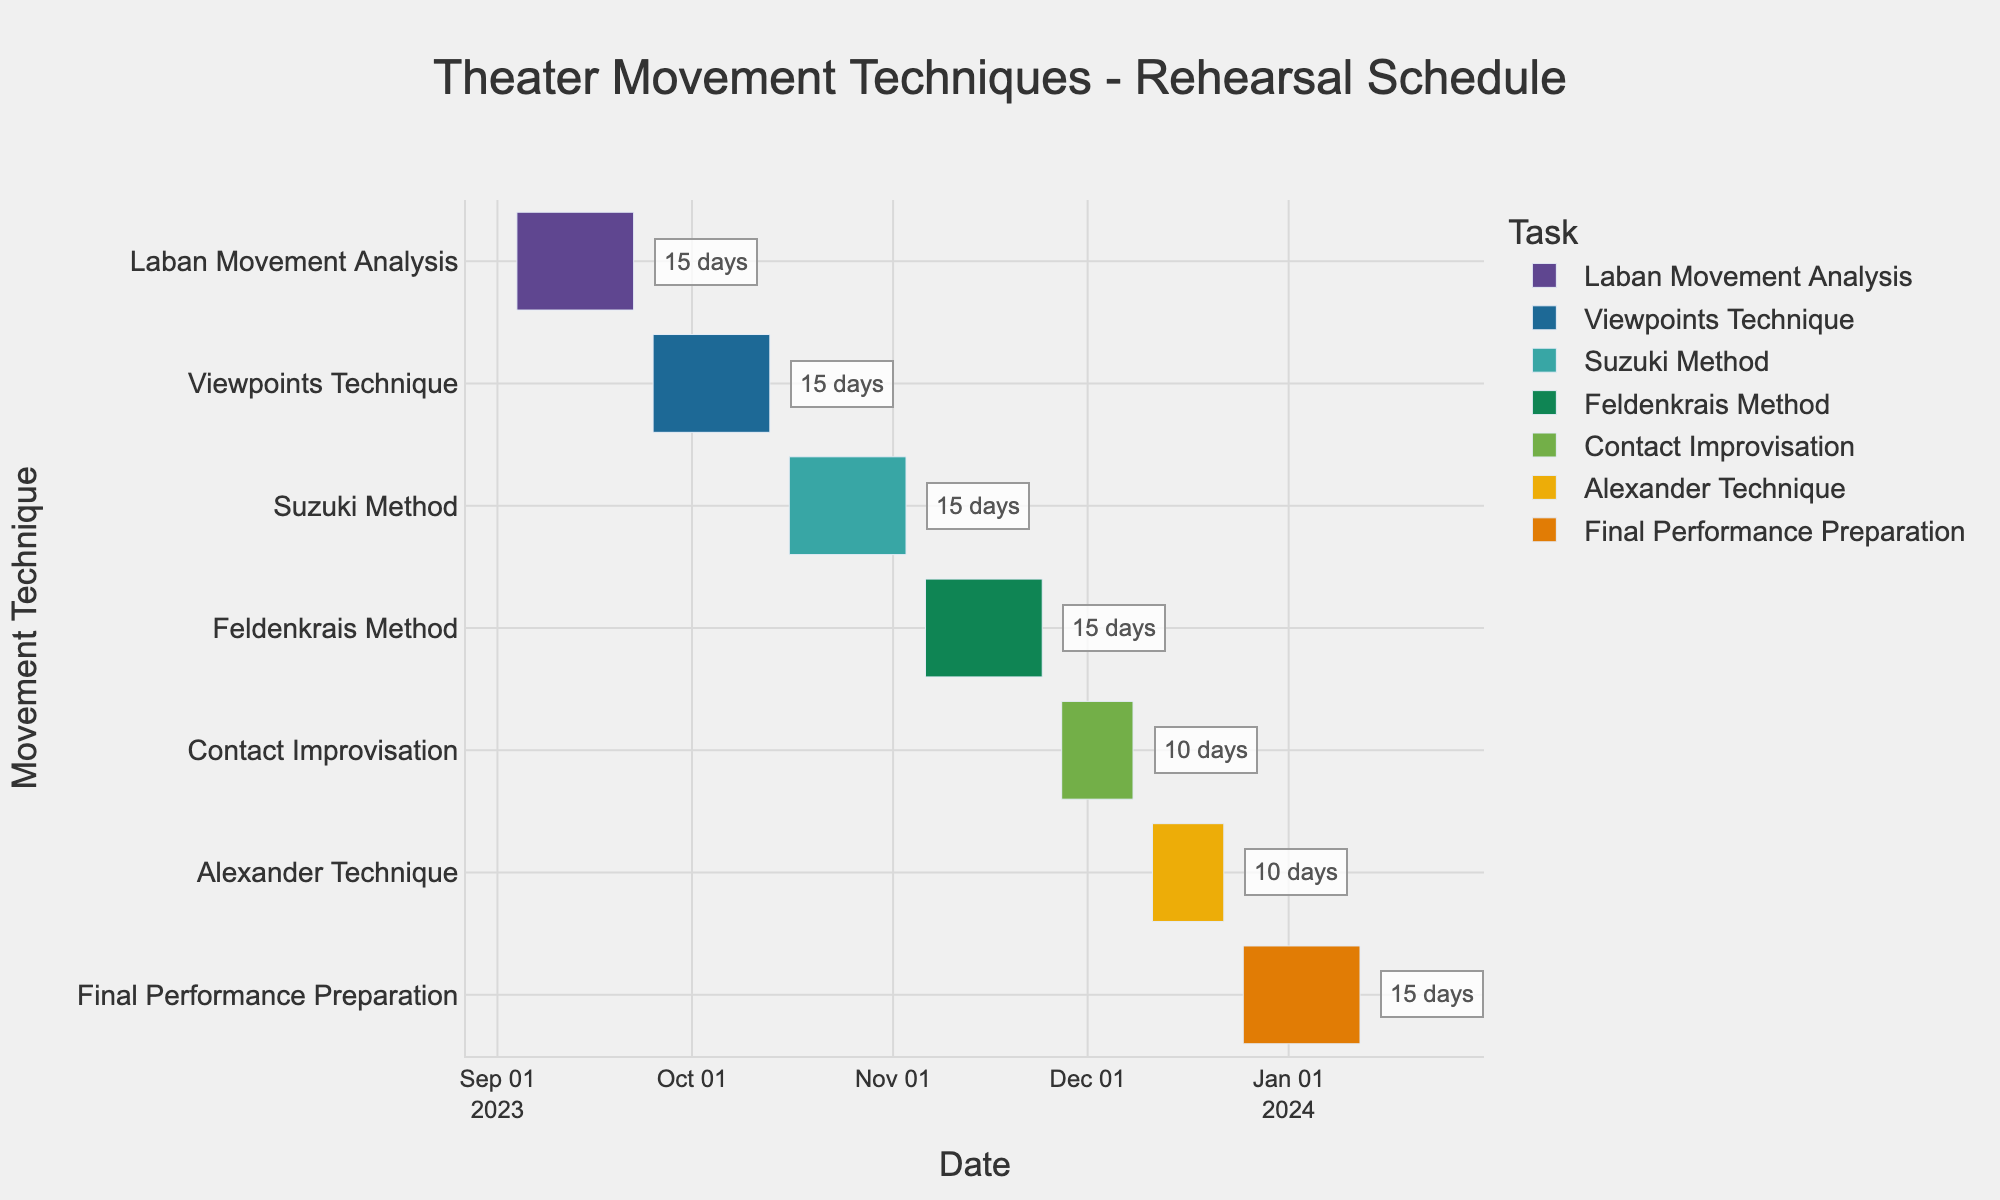What's the title of the Gantt Chart? The title can be found at the top of the chart and usually summarizes the content.
Answer: Theater Movement Techniques - Rehearsal Schedule What is the duration of the Suzuki Method rehearsal period? The duration can be found by looking at the annotation next to the Suzuki Method bar within the Gantt Chart.
Answer: 15 days Which movement technique is scheduled to start first? The first technique scheduled can be identified by looking at which task has the earliest start date on the x-axis.
Answer: Laban Movement Analysis How long is the Final Performance Preparation scheduled to last? The duration can be seen in the annotation next to the Final Performance Preparation bar within the Gantt Chart.
Answer: 15 days Between which dates does the Contact Improvisation rehearsal period fall? The start and end dates for Contact Improvisation can be found next to its bar on the y-axis.
Answer: November 27, 2023 to December 8, 2023 Compare the duration of Alexander Technique and Contact Improvisation. Which one is shorter? By looking at the durations annotated next to each bar, compare the two values. Alexander Technique lasts 10 days, which is the same as Contact Improvisation.
Answer: Equal How many techniques are rehearsed before November 2023? Check the end dates of each technique and count those that finish before November 1, 2023. They are: Laban Movement Analysis, Viewpoints Technique, and Suzuki Method. So, there are three techniques.
Answer: 3 Which technique has the shortest duration and what is it? By comparing the durations annotated next to each technique's bar, the shortest duration can be found. Both Contact Improvisation and Alexander Technique have durations of 10 days.
Answer: Contact Improvisation and Alexander Technique What is the total duration of rehearsals for the techniques scheduled in December 2023? Identify the techniques in December: Contact Improvisation, Alexander Technique, and part of Final Performance Preparation. Sum their durations: 10 + 10 + part of 15 days in December.
Answer: 35 days What are the start and end dates of the Viewpoints Technique rehearsal period? These dates can be found by looking at the start and end dates next to the Viewpoints Technique bar on the y-axis.
Answer: September 25, 2023 to October 13, 2023 